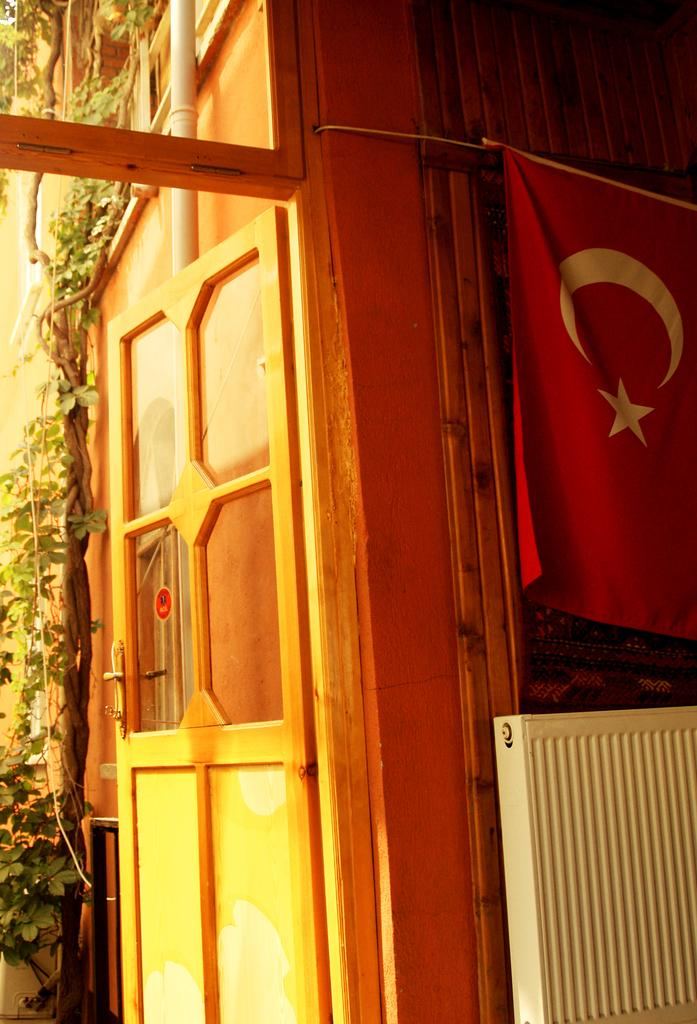What can be found in the image that serves as an entrance or exit? There is a door in the image. What colors are used to paint the door? The door is yellow and orange in color. What is the other vertical object in the image that represents a symbol or country? There is a flag in the image, and it is red and white in color. What is the long, cylindrical object in the image that carries fluids or gases? There is a pipe in the image. What type of plant can be seen in the image? There is a tree in the image. What is the white-colored object in the image? There is a white-colored object in the image, but its specific purpose or identity is not mentioned in the facts. How many sacks are being carried by the ray across the bridge in the image? There are no sacks, rays, or bridges present in the image. 